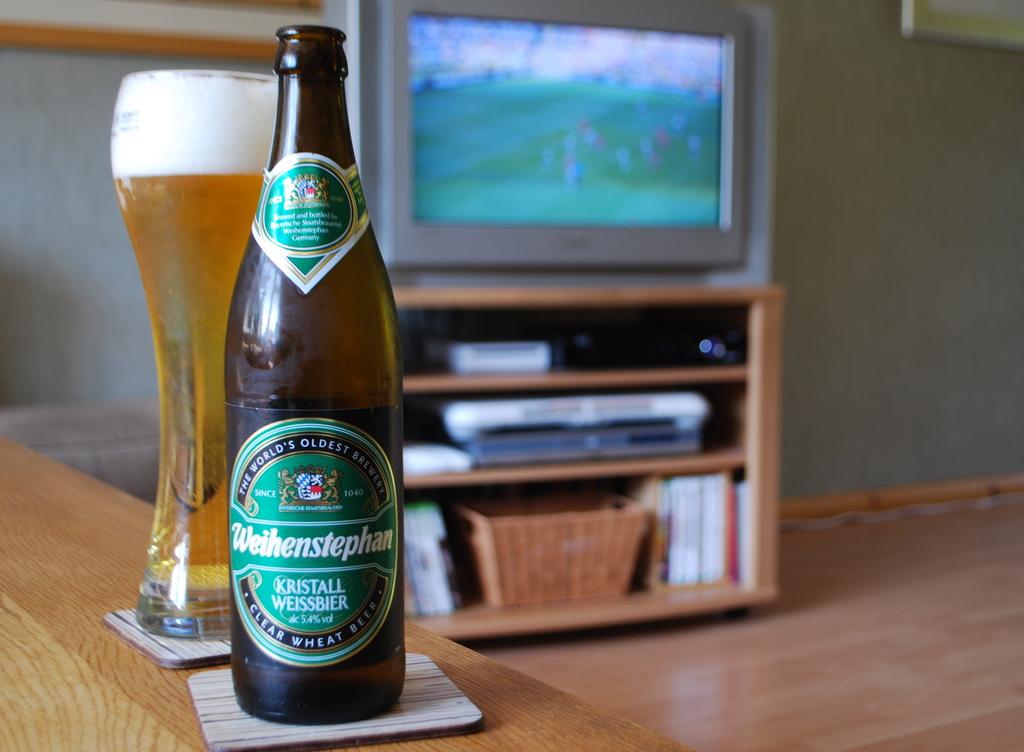Where is that beer brewed?
Provide a succinct answer. Unanswerable. 